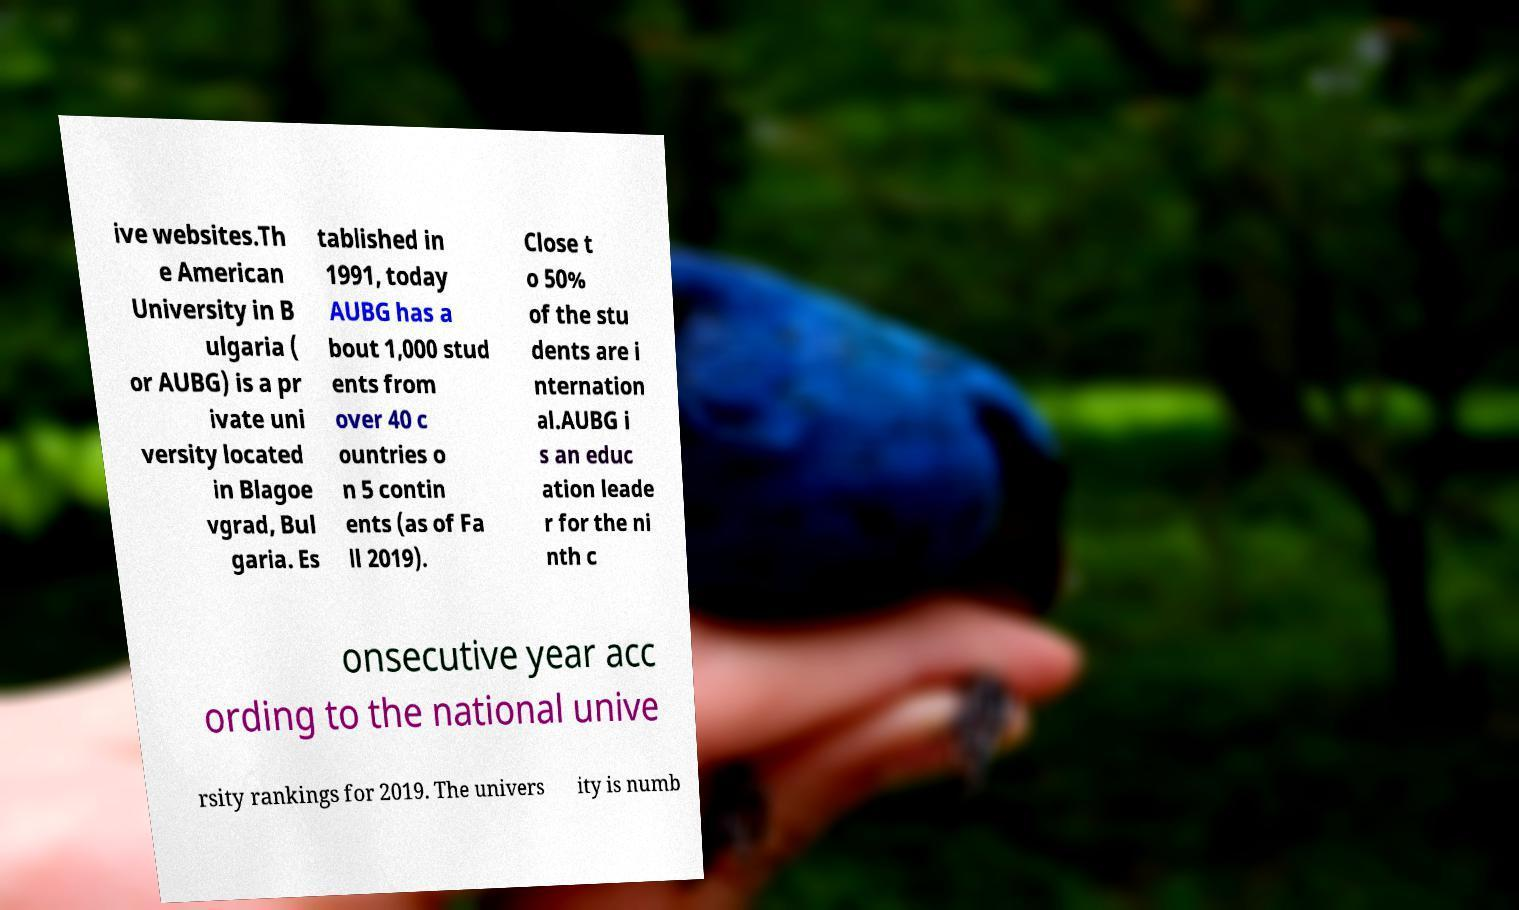Could you assist in decoding the text presented in this image and type it out clearly? ive websites.Th e American University in B ulgaria ( or AUBG) is a pr ivate uni versity located in Blagoe vgrad, Bul garia. Es tablished in 1991, today AUBG has a bout 1,000 stud ents from over 40 c ountries o n 5 contin ents (as of Fa ll 2019). Close t o 50% of the stu dents are i nternation al.AUBG i s an educ ation leade r for the ni nth c onsecutive year acc ording to the national unive rsity rankings for 2019. The univers ity is numb 